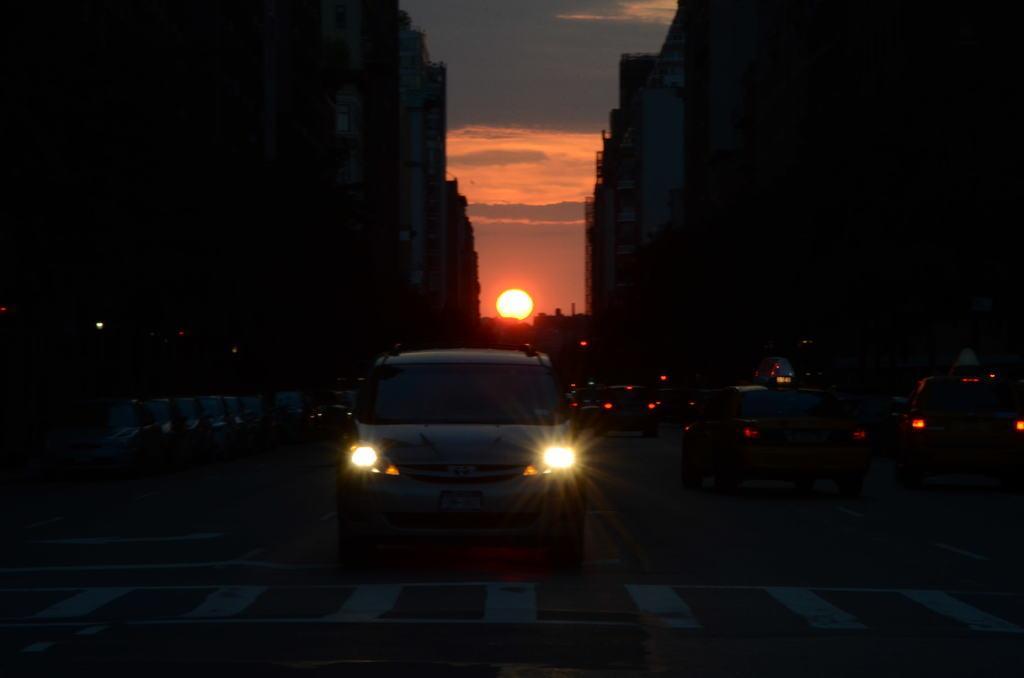Could you give a brief overview of what you see in this image? In this image I can see few buildings, vehicles, lights, sky and the sun. The image is dark. 